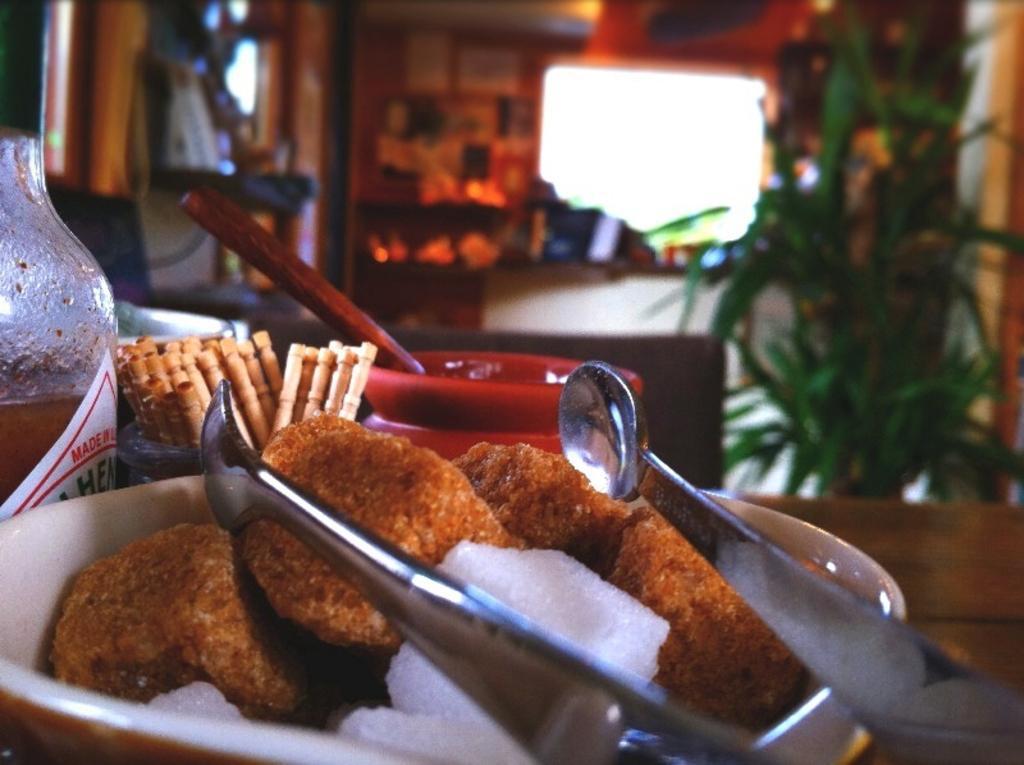Can you describe this image briefly? In this image we can see food item in a bowl. There are few objects behind the bowl. On the right side, we can see a wall and a plant. The background of the image is blurred. 